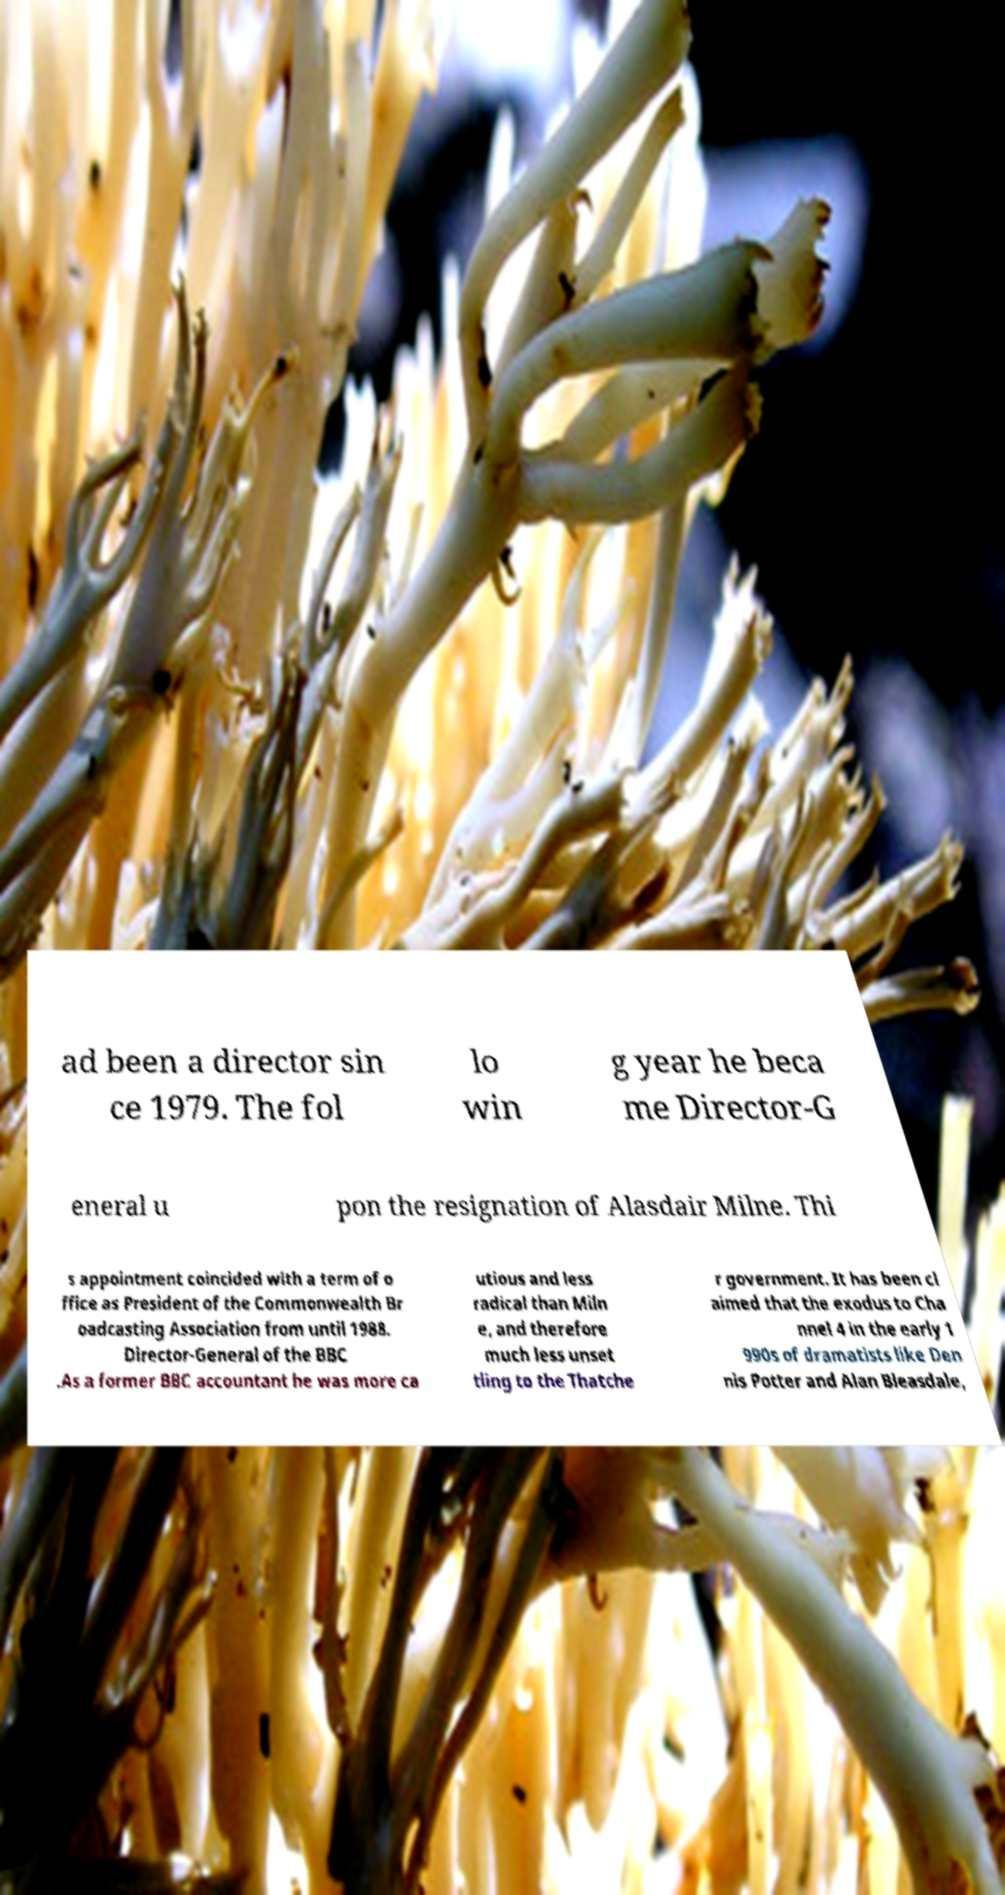Could you extract and type out the text from this image? ad been a director sin ce 1979. The fol lo win g year he beca me Director-G eneral u pon the resignation of Alasdair Milne. Thi s appointment coincided with a term of o ffice as President of the Commonwealth Br oadcasting Association from until 1988. Director-General of the BBC .As a former BBC accountant he was more ca utious and less radical than Miln e, and therefore much less unset tling to the Thatche r government. It has been cl aimed that the exodus to Cha nnel 4 in the early 1 990s of dramatists like Den nis Potter and Alan Bleasdale, 